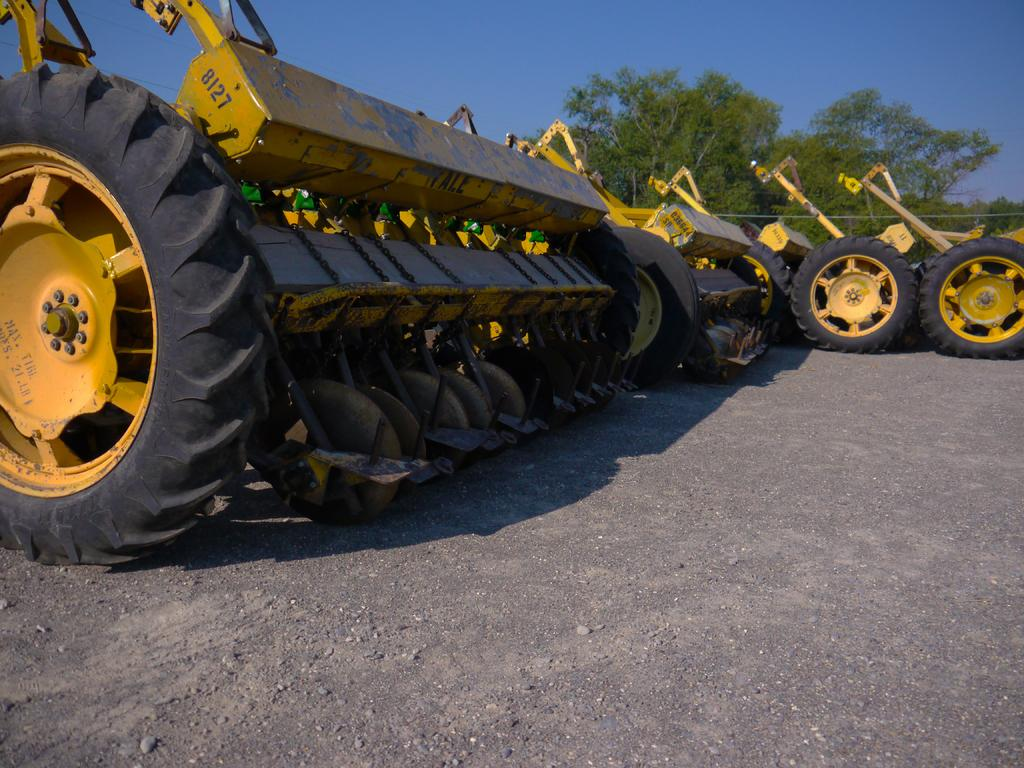What type of vehicles are present in the image? There are tractors in the image. What color are the tractors? The tractors are yellow. What can be seen in the background of the image? There is sky and trees visible in the background of the image. How many people are swimming in the image? There are no people swimming in the image; it features tractors and a background with sky and trees. What type of military vehicle is present in the image? There is no military vehicle, such as a tank, present in the image. 